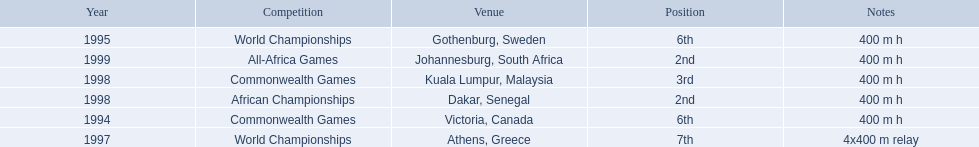What races did ken harden run? 400 m h, 400 m h, 4x400 m relay, 400 m h, 400 m h, 400 m h. Which race did ken harden run in 1997? 4x400 m relay. 